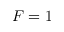<formula> <loc_0><loc_0><loc_500><loc_500>F = 1</formula> 